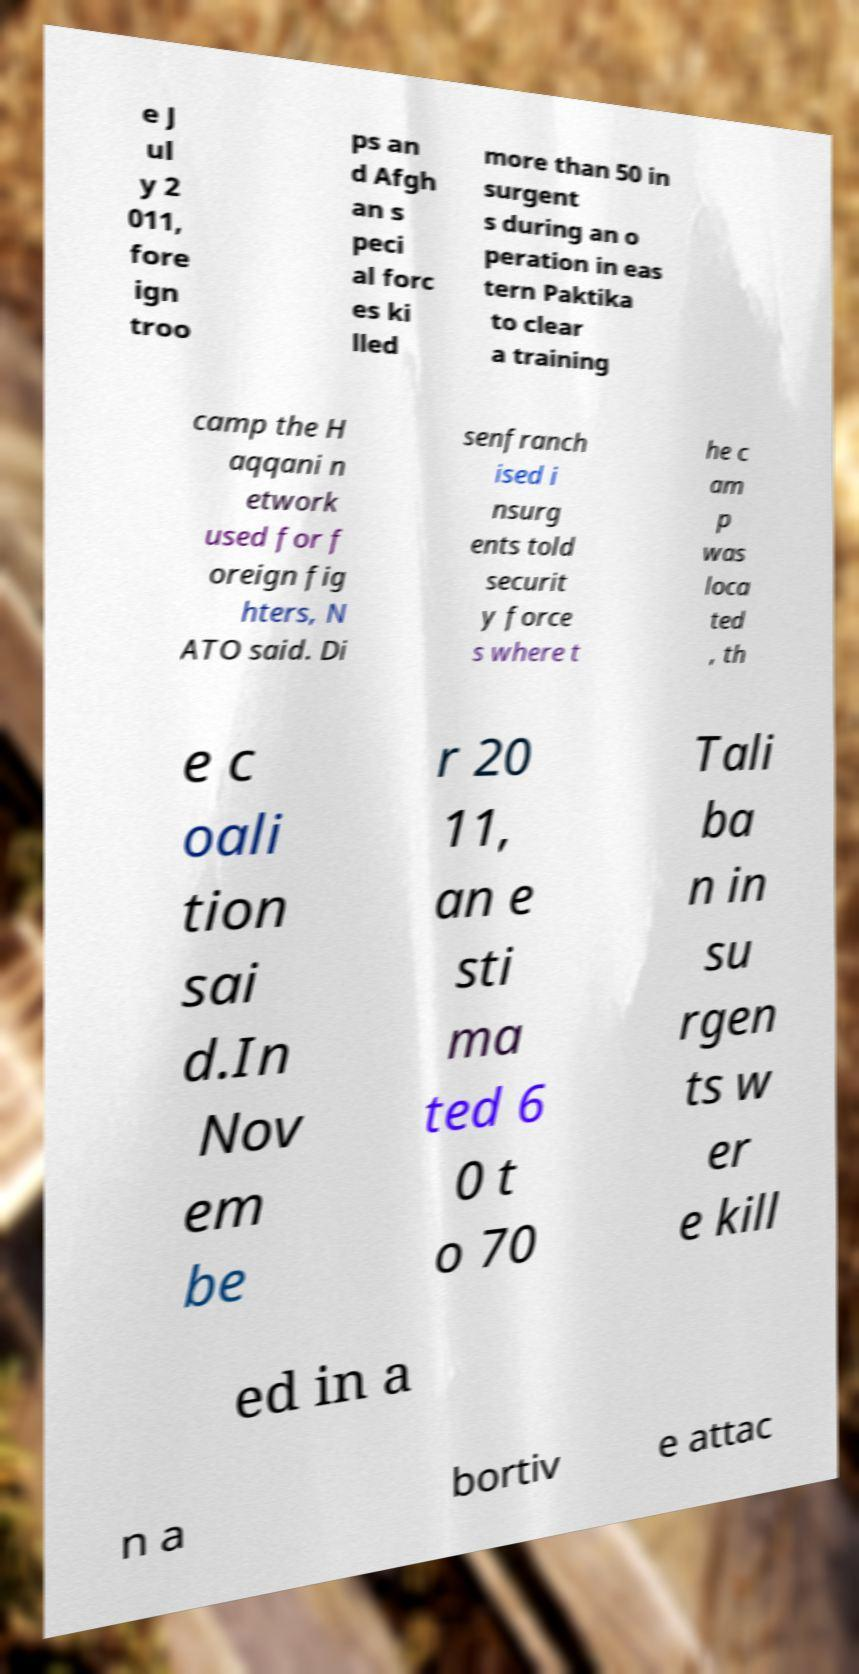Can you accurately transcribe the text from the provided image for me? e J ul y 2 011, fore ign troo ps an d Afgh an s peci al forc es ki lled more than 50 in surgent s during an o peration in eas tern Paktika to clear a training camp the H aqqani n etwork used for f oreign fig hters, N ATO said. Di senfranch ised i nsurg ents told securit y force s where t he c am p was loca ted , th e c oali tion sai d.In Nov em be r 20 11, an e sti ma ted 6 0 t o 70 Tali ba n in su rgen ts w er e kill ed in a n a bortiv e attac 